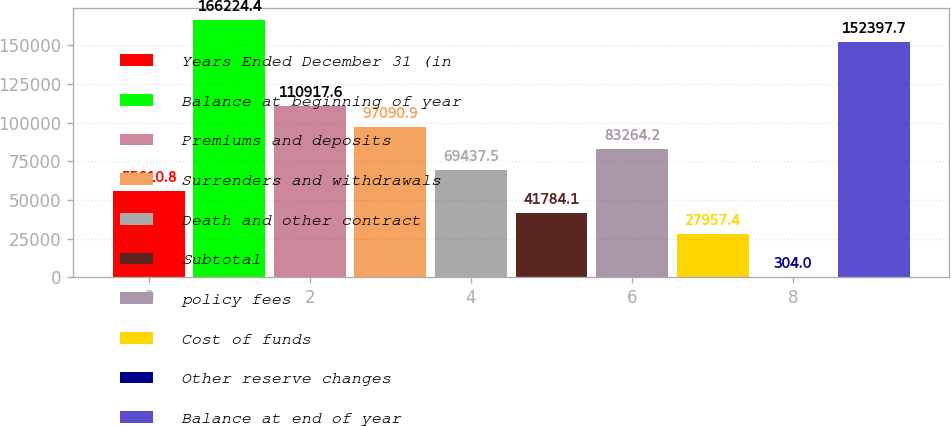<chart> <loc_0><loc_0><loc_500><loc_500><bar_chart><fcel>Years Ended December 31 (in<fcel>Balance at beginning of year<fcel>Premiums and deposits<fcel>Surrenders and withdrawals<fcel>Death and other contract<fcel>Subtotal<fcel>policy fees<fcel>Cost of funds<fcel>Other reserve changes<fcel>Balance at end of year<nl><fcel>55610.8<fcel>166224<fcel>110918<fcel>97090.9<fcel>69437.5<fcel>41784.1<fcel>83264.2<fcel>27957.4<fcel>304<fcel>152398<nl></chart> 